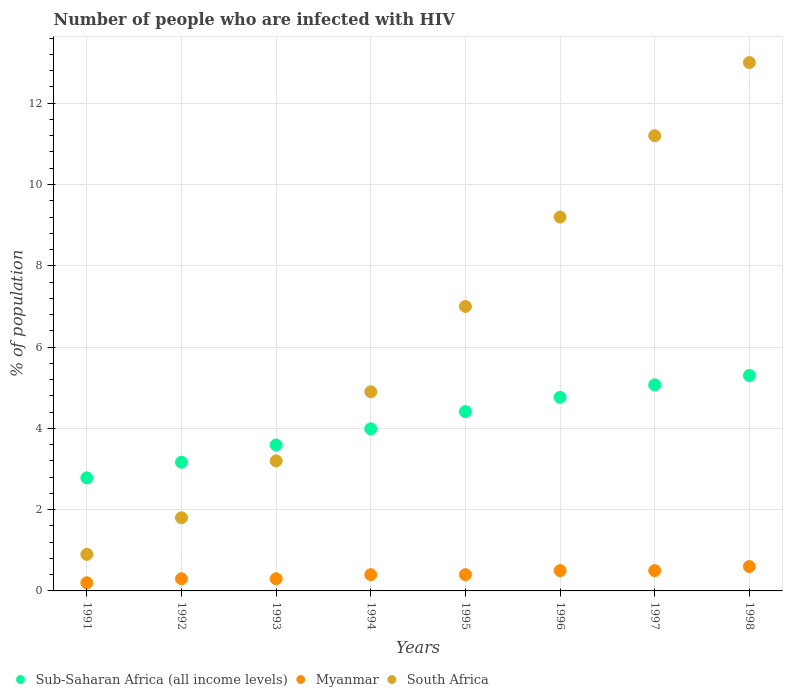What is the percentage of HIV infected population in in South Africa in 1993?
Make the answer very short. 3.2. Across all years, what is the minimum percentage of HIV infected population in in Sub-Saharan Africa (all income levels)?
Offer a terse response. 2.78. In which year was the percentage of HIV infected population in in Sub-Saharan Africa (all income levels) maximum?
Provide a succinct answer. 1998. In which year was the percentage of HIV infected population in in Myanmar minimum?
Give a very brief answer. 1991. What is the total percentage of HIV infected population in in South Africa in the graph?
Provide a succinct answer. 51.2. What is the difference between the percentage of HIV infected population in in Sub-Saharan Africa (all income levels) in 1991 and that in 1996?
Offer a terse response. -1.98. What is the average percentage of HIV infected population in in Sub-Saharan Africa (all income levels) per year?
Offer a very short reply. 4.13. In the year 1998, what is the difference between the percentage of HIV infected population in in Myanmar and percentage of HIV infected population in in South Africa?
Give a very brief answer. -12.4. What is the ratio of the percentage of HIV infected population in in South Africa in 1994 to that in 1996?
Provide a succinct answer. 0.53. Is the difference between the percentage of HIV infected population in in Myanmar in 1992 and 1997 greater than the difference between the percentage of HIV infected population in in South Africa in 1992 and 1997?
Offer a terse response. Yes. What is the difference between the highest and the second highest percentage of HIV infected population in in South Africa?
Make the answer very short. 1.8. What is the difference between the highest and the lowest percentage of HIV infected population in in Myanmar?
Give a very brief answer. 0.4. In how many years, is the percentage of HIV infected population in in Myanmar greater than the average percentage of HIV infected population in in Myanmar taken over all years?
Keep it short and to the point. 3. Does the percentage of HIV infected population in in South Africa monotonically increase over the years?
Provide a short and direct response. Yes. Is the percentage of HIV infected population in in Myanmar strictly greater than the percentage of HIV infected population in in South Africa over the years?
Make the answer very short. No. How many dotlines are there?
Provide a short and direct response. 3. What is the difference between two consecutive major ticks on the Y-axis?
Your answer should be very brief. 2. Are the values on the major ticks of Y-axis written in scientific E-notation?
Offer a very short reply. No. Where does the legend appear in the graph?
Your answer should be compact. Bottom left. What is the title of the graph?
Provide a short and direct response. Number of people who are infected with HIV. Does "Samoa" appear as one of the legend labels in the graph?
Your response must be concise. No. What is the label or title of the Y-axis?
Make the answer very short. % of population. What is the % of population in Sub-Saharan Africa (all income levels) in 1991?
Ensure brevity in your answer.  2.78. What is the % of population in Sub-Saharan Africa (all income levels) in 1992?
Keep it short and to the point. 3.17. What is the % of population of South Africa in 1992?
Give a very brief answer. 1.8. What is the % of population of Sub-Saharan Africa (all income levels) in 1993?
Ensure brevity in your answer.  3.59. What is the % of population in Myanmar in 1993?
Make the answer very short. 0.3. What is the % of population in Sub-Saharan Africa (all income levels) in 1994?
Provide a succinct answer. 3.99. What is the % of population of Sub-Saharan Africa (all income levels) in 1995?
Offer a very short reply. 4.41. What is the % of population in Myanmar in 1995?
Your answer should be very brief. 0.4. What is the % of population in South Africa in 1995?
Provide a succinct answer. 7. What is the % of population of Sub-Saharan Africa (all income levels) in 1996?
Make the answer very short. 4.76. What is the % of population in Sub-Saharan Africa (all income levels) in 1997?
Offer a very short reply. 5.07. What is the % of population of Myanmar in 1997?
Your response must be concise. 0.5. What is the % of population in Sub-Saharan Africa (all income levels) in 1998?
Offer a very short reply. 5.3. What is the % of population in Myanmar in 1998?
Provide a succinct answer. 0.6. Across all years, what is the maximum % of population in Sub-Saharan Africa (all income levels)?
Make the answer very short. 5.3. Across all years, what is the minimum % of population of Sub-Saharan Africa (all income levels)?
Give a very brief answer. 2.78. Across all years, what is the minimum % of population in Myanmar?
Ensure brevity in your answer.  0.2. What is the total % of population of Sub-Saharan Africa (all income levels) in the graph?
Your answer should be compact. 33.07. What is the total % of population in South Africa in the graph?
Your answer should be compact. 51.2. What is the difference between the % of population of Sub-Saharan Africa (all income levels) in 1991 and that in 1992?
Keep it short and to the point. -0.38. What is the difference between the % of population of Sub-Saharan Africa (all income levels) in 1991 and that in 1993?
Offer a terse response. -0.81. What is the difference between the % of population of South Africa in 1991 and that in 1993?
Keep it short and to the point. -2.3. What is the difference between the % of population in Sub-Saharan Africa (all income levels) in 1991 and that in 1994?
Your answer should be compact. -1.21. What is the difference between the % of population in Myanmar in 1991 and that in 1994?
Provide a succinct answer. -0.2. What is the difference between the % of population in South Africa in 1991 and that in 1994?
Make the answer very short. -4. What is the difference between the % of population in Sub-Saharan Africa (all income levels) in 1991 and that in 1995?
Keep it short and to the point. -1.63. What is the difference between the % of population of Sub-Saharan Africa (all income levels) in 1991 and that in 1996?
Offer a very short reply. -1.98. What is the difference between the % of population of Myanmar in 1991 and that in 1996?
Provide a short and direct response. -0.3. What is the difference between the % of population in South Africa in 1991 and that in 1996?
Provide a short and direct response. -8.3. What is the difference between the % of population in Sub-Saharan Africa (all income levels) in 1991 and that in 1997?
Provide a short and direct response. -2.29. What is the difference between the % of population of Sub-Saharan Africa (all income levels) in 1991 and that in 1998?
Your response must be concise. -2.52. What is the difference between the % of population of Myanmar in 1991 and that in 1998?
Make the answer very short. -0.4. What is the difference between the % of population of Sub-Saharan Africa (all income levels) in 1992 and that in 1993?
Offer a very short reply. -0.42. What is the difference between the % of population of Myanmar in 1992 and that in 1993?
Offer a terse response. 0. What is the difference between the % of population in South Africa in 1992 and that in 1993?
Keep it short and to the point. -1.4. What is the difference between the % of population of Sub-Saharan Africa (all income levels) in 1992 and that in 1994?
Offer a very short reply. -0.82. What is the difference between the % of population of Sub-Saharan Africa (all income levels) in 1992 and that in 1995?
Provide a succinct answer. -1.25. What is the difference between the % of population in Myanmar in 1992 and that in 1995?
Give a very brief answer. -0.1. What is the difference between the % of population of Sub-Saharan Africa (all income levels) in 1992 and that in 1996?
Keep it short and to the point. -1.6. What is the difference between the % of population of Myanmar in 1992 and that in 1996?
Offer a terse response. -0.2. What is the difference between the % of population of Sub-Saharan Africa (all income levels) in 1992 and that in 1997?
Ensure brevity in your answer.  -1.9. What is the difference between the % of population in Sub-Saharan Africa (all income levels) in 1992 and that in 1998?
Offer a terse response. -2.14. What is the difference between the % of population of Myanmar in 1992 and that in 1998?
Keep it short and to the point. -0.3. What is the difference between the % of population in South Africa in 1992 and that in 1998?
Make the answer very short. -11.2. What is the difference between the % of population in Sub-Saharan Africa (all income levels) in 1993 and that in 1994?
Ensure brevity in your answer.  -0.4. What is the difference between the % of population in Sub-Saharan Africa (all income levels) in 1993 and that in 1995?
Make the answer very short. -0.82. What is the difference between the % of population in Sub-Saharan Africa (all income levels) in 1993 and that in 1996?
Your answer should be very brief. -1.17. What is the difference between the % of population of South Africa in 1993 and that in 1996?
Your response must be concise. -6. What is the difference between the % of population in Sub-Saharan Africa (all income levels) in 1993 and that in 1997?
Give a very brief answer. -1.48. What is the difference between the % of population in Myanmar in 1993 and that in 1997?
Provide a succinct answer. -0.2. What is the difference between the % of population of South Africa in 1993 and that in 1997?
Offer a very short reply. -8. What is the difference between the % of population of Sub-Saharan Africa (all income levels) in 1993 and that in 1998?
Your answer should be very brief. -1.71. What is the difference between the % of population in Sub-Saharan Africa (all income levels) in 1994 and that in 1995?
Provide a short and direct response. -0.42. What is the difference between the % of population of Myanmar in 1994 and that in 1995?
Keep it short and to the point. 0. What is the difference between the % of population of Sub-Saharan Africa (all income levels) in 1994 and that in 1996?
Provide a succinct answer. -0.77. What is the difference between the % of population in South Africa in 1994 and that in 1996?
Give a very brief answer. -4.3. What is the difference between the % of population of Sub-Saharan Africa (all income levels) in 1994 and that in 1997?
Keep it short and to the point. -1.08. What is the difference between the % of population of South Africa in 1994 and that in 1997?
Provide a succinct answer. -6.3. What is the difference between the % of population of Sub-Saharan Africa (all income levels) in 1994 and that in 1998?
Make the answer very short. -1.31. What is the difference between the % of population of Sub-Saharan Africa (all income levels) in 1995 and that in 1996?
Provide a short and direct response. -0.35. What is the difference between the % of population in Myanmar in 1995 and that in 1996?
Your answer should be compact. -0.1. What is the difference between the % of population in Sub-Saharan Africa (all income levels) in 1995 and that in 1997?
Offer a terse response. -0.66. What is the difference between the % of population in Myanmar in 1995 and that in 1997?
Provide a succinct answer. -0.1. What is the difference between the % of population in Sub-Saharan Africa (all income levels) in 1995 and that in 1998?
Make the answer very short. -0.89. What is the difference between the % of population in Sub-Saharan Africa (all income levels) in 1996 and that in 1997?
Keep it short and to the point. -0.31. What is the difference between the % of population of Myanmar in 1996 and that in 1997?
Your response must be concise. 0. What is the difference between the % of population of Sub-Saharan Africa (all income levels) in 1996 and that in 1998?
Ensure brevity in your answer.  -0.54. What is the difference between the % of population in Myanmar in 1996 and that in 1998?
Ensure brevity in your answer.  -0.1. What is the difference between the % of population of Sub-Saharan Africa (all income levels) in 1997 and that in 1998?
Give a very brief answer. -0.23. What is the difference between the % of population in Myanmar in 1997 and that in 1998?
Your answer should be compact. -0.1. What is the difference between the % of population of South Africa in 1997 and that in 1998?
Make the answer very short. -1.8. What is the difference between the % of population of Sub-Saharan Africa (all income levels) in 1991 and the % of population of Myanmar in 1992?
Offer a very short reply. 2.48. What is the difference between the % of population of Sub-Saharan Africa (all income levels) in 1991 and the % of population of South Africa in 1992?
Provide a succinct answer. 0.98. What is the difference between the % of population in Sub-Saharan Africa (all income levels) in 1991 and the % of population in Myanmar in 1993?
Your response must be concise. 2.48. What is the difference between the % of population of Sub-Saharan Africa (all income levels) in 1991 and the % of population of South Africa in 1993?
Ensure brevity in your answer.  -0.42. What is the difference between the % of population of Sub-Saharan Africa (all income levels) in 1991 and the % of population of Myanmar in 1994?
Your response must be concise. 2.38. What is the difference between the % of population in Sub-Saharan Africa (all income levels) in 1991 and the % of population in South Africa in 1994?
Offer a very short reply. -2.12. What is the difference between the % of population of Myanmar in 1991 and the % of population of South Africa in 1994?
Offer a terse response. -4.7. What is the difference between the % of population in Sub-Saharan Africa (all income levels) in 1991 and the % of population in Myanmar in 1995?
Your response must be concise. 2.38. What is the difference between the % of population in Sub-Saharan Africa (all income levels) in 1991 and the % of population in South Africa in 1995?
Keep it short and to the point. -4.22. What is the difference between the % of population in Sub-Saharan Africa (all income levels) in 1991 and the % of population in Myanmar in 1996?
Ensure brevity in your answer.  2.28. What is the difference between the % of population in Sub-Saharan Africa (all income levels) in 1991 and the % of population in South Africa in 1996?
Make the answer very short. -6.42. What is the difference between the % of population of Myanmar in 1991 and the % of population of South Africa in 1996?
Ensure brevity in your answer.  -9. What is the difference between the % of population in Sub-Saharan Africa (all income levels) in 1991 and the % of population in Myanmar in 1997?
Provide a short and direct response. 2.28. What is the difference between the % of population in Sub-Saharan Africa (all income levels) in 1991 and the % of population in South Africa in 1997?
Your answer should be very brief. -8.42. What is the difference between the % of population of Myanmar in 1991 and the % of population of South Africa in 1997?
Give a very brief answer. -11. What is the difference between the % of population of Sub-Saharan Africa (all income levels) in 1991 and the % of population of Myanmar in 1998?
Offer a very short reply. 2.18. What is the difference between the % of population in Sub-Saharan Africa (all income levels) in 1991 and the % of population in South Africa in 1998?
Your response must be concise. -10.22. What is the difference between the % of population of Sub-Saharan Africa (all income levels) in 1992 and the % of population of Myanmar in 1993?
Offer a very short reply. 2.87. What is the difference between the % of population in Sub-Saharan Africa (all income levels) in 1992 and the % of population in South Africa in 1993?
Give a very brief answer. -0.03. What is the difference between the % of population of Myanmar in 1992 and the % of population of South Africa in 1993?
Your answer should be very brief. -2.9. What is the difference between the % of population of Sub-Saharan Africa (all income levels) in 1992 and the % of population of Myanmar in 1994?
Provide a succinct answer. 2.77. What is the difference between the % of population of Sub-Saharan Africa (all income levels) in 1992 and the % of population of South Africa in 1994?
Offer a very short reply. -1.73. What is the difference between the % of population in Myanmar in 1992 and the % of population in South Africa in 1994?
Your answer should be very brief. -4.6. What is the difference between the % of population in Sub-Saharan Africa (all income levels) in 1992 and the % of population in Myanmar in 1995?
Offer a very short reply. 2.77. What is the difference between the % of population of Sub-Saharan Africa (all income levels) in 1992 and the % of population of South Africa in 1995?
Your response must be concise. -3.83. What is the difference between the % of population of Sub-Saharan Africa (all income levels) in 1992 and the % of population of Myanmar in 1996?
Offer a terse response. 2.67. What is the difference between the % of population of Sub-Saharan Africa (all income levels) in 1992 and the % of population of South Africa in 1996?
Keep it short and to the point. -6.03. What is the difference between the % of population of Myanmar in 1992 and the % of population of South Africa in 1996?
Make the answer very short. -8.9. What is the difference between the % of population of Sub-Saharan Africa (all income levels) in 1992 and the % of population of Myanmar in 1997?
Your answer should be very brief. 2.67. What is the difference between the % of population in Sub-Saharan Africa (all income levels) in 1992 and the % of population in South Africa in 1997?
Provide a short and direct response. -8.03. What is the difference between the % of population of Sub-Saharan Africa (all income levels) in 1992 and the % of population of Myanmar in 1998?
Offer a terse response. 2.57. What is the difference between the % of population in Sub-Saharan Africa (all income levels) in 1992 and the % of population in South Africa in 1998?
Offer a very short reply. -9.83. What is the difference between the % of population in Myanmar in 1992 and the % of population in South Africa in 1998?
Keep it short and to the point. -12.7. What is the difference between the % of population of Sub-Saharan Africa (all income levels) in 1993 and the % of population of Myanmar in 1994?
Make the answer very short. 3.19. What is the difference between the % of population in Sub-Saharan Africa (all income levels) in 1993 and the % of population in South Africa in 1994?
Offer a very short reply. -1.31. What is the difference between the % of population of Sub-Saharan Africa (all income levels) in 1993 and the % of population of Myanmar in 1995?
Provide a short and direct response. 3.19. What is the difference between the % of population of Sub-Saharan Africa (all income levels) in 1993 and the % of population of South Africa in 1995?
Provide a succinct answer. -3.41. What is the difference between the % of population of Myanmar in 1993 and the % of population of South Africa in 1995?
Your answer should be compact. -6.7. What is the difference between the % of population of Sub-Saharan Africa (all income levels) in 1993 and the % of population of Myanmar in 1996?
Your answer should be compact. 3.09. What is the difference between the % of population in Sub-Saharan Africa (all income levels) in 1993 and the % of population in South Africa in 1996?
Make the answer very short. -5.61. What is the difference between the % of population of Sub-Saharan Africa (all income levels) in 1993 and the % of population of Myanmar in 1997?
Make the answer very short. 3.09. What is the difference between the % of population in Sub-Saharan Africa (all income levels) in 1993 and the % of population in South Africa in 1997?
Your answer should be very brief. -7.61. What is the difference between the % of population in Myanmar in 1993 and the % of population in South Africa in 1997?
Your answer should be compact. -10.9. What is the difference between the % of population of Sub-Saharan Africa (all income levels) in 1993 and the % of population of Myanmar in 1998?
Offer a very short reply. 2.99. What is the difference between the % of population in Sub-Saharan Africa (all income levels) in 1993 and the % of population in South Africa in 1998?
Provide a succinct answer. -9.41. What is the difference between the % of population of Sub-Saharan Africa (all income levels) in 1994 and the % of population of Myanmar in 1995?
Keep it short and to the point. 3.59. What is the difference between the % of population of Sub-Saharan Africa (all income levels) in 1994 and the % of population of South Africa in 1995?
Provide a succinct answer. -3.01. What is the difference between the % of population of Myanmar in 1994 and the % of population of South Africa in 1995?
Keep it short and to the point. -6.6. What is the difference between the % of population in Sub-Saharan Africa (all income levels) in 1994 and the % of population in Myanmar in 1996?
Ensure brevity in your answer.  3.49. What is the difference between the % of population in Sub-Saharan Africa (all income levels) in 1994 and the % of population in South Africa in 1996?
Your response must be concise. -5.21. What is the difference between the % of population of Myanmar in 1994 and the % of population of South Africa in 1996?
Give a very brief answer. -8.8. What is the difference between the % of population of Sub-Saharan Africa (all income levels) in 1994 and the % of population of Myanmar in 1997?
Ensure brevity in your answer.  3.49. What is the difference between the % of population in Sub-Saharan Africa (all income levels) in 1994 and the % of population in South Africa in 1997?
Your answer should be compact. -7.21. What is the difference between the % of population in Sub-Saharan Africa (all income levels) in 1994 and the % of population in Myanmar in 1998?
Offer a terse response. 3.39. What is the difference between the % of population in Sub-Saharan Africa (all income levels) in 1994 and the % of population in South Africa in 1998?
Give a very brief answer. -9.01. What is the difference between the % of population in Myanmar in 1994 and the % of population in South Africa in 1998?
Provide a short and direct response. -12.6. What is the difference between the % of population in Sub-Saharan Africa (all income levels) in 1995 and the % of population in Myanmar in 1996?
Offer a terse response. 3.91. What is the difference between the % of population of Sub-Saharan Africa (all income levels) in 1995 and the % of population of South Africa in 1996?
Your response must be concise. -4.79. What is the difference between the % of population in Myanmar in 1995 and the % of population in South Africa in 1996?
Provide a succinct answer. -8.8. What is the difference between the % of population in Sub-Saharan Africa (all income levels) in 1995 and the % of population in Myanmar in 1997?
Offer a terse response. 3.91. What is the difference between the % of population of Sub-Saharan Africa (all income levels) in 1995 and the % of population of South Africa in 1997?
Offer a terse response. -6.79. What is the difference between the % of population in Myanmar in 1995 and the % of population in South Africa in 1997?
Provide a succinct answer. -10.8. What is the difference between the % of population in Sub-Saharan Africa (all income levels) in 1995 and the % of population in Myanmar in 1998?
Give a very brief answer. 3.81. What is the difference between the % of population in Sub-Saharan Africa (all income levels) in 1995 and the % of population in South Africa in 1998?
Your answer should be very brief. -8.59. What is the difference between the % of population of Myanmar in 1995 and the % of population of South Africa in 1998?
Make the answer very short. -12.6. What is the difference between the % of population in Sub-Saharan Africa (all income levels) in 1996 and the % of population in Myanmar in 1997?
Make the answer very short. 4.26. What is the difference between the % of population in Sub-Saharan Africa (all income levels) in 1996 and the % of population in South Africa in 1997?
Offer a terse response. -6.44. What is the difference between the % of population in Myanmar in 1996 and the % of population in South Africa in 1997?
Offer a terse response. -10.7. What is the difference between the % of population of Sub-Saharan Africa (all income levels) in 1996 and the % of population of Myanmar in 1998?
Your answer should be compact. 4.16. What is the difference between the % of population in Sub-Saharan Africa (all income levels) in 1996 and the % of population in South Africa in 1998?
Provide a succinct answer. -8.24. What is the difference between the % of population of Sub-Saharan Africa (all income levels) in 1997 and the % of population of Myanmar in 1998?
Keep it short and to the point. 4.47. What is the difference between the % of population of Sub-Saharan Africa (all income levels) in 1997 and the % of population of South Africa in 1998?
Your response must be concise. -7.93. What is the average % of population in Sub-Saharan Africa (all income levels) per year?
Your response must be concise. 4.13. What is the average % of population of Myanmar per year?
Your answer should be compact. 0.4. In the year 1991, what is the difference between the % of population of Sub-Saharan Africa (all income levels) and % of population of Myanmar?
Offer a terse response. 2.58. In the year 1991, what is the difference between the % of population in Sub-Saharan Africa (all income levels) and % of population in South Africa?
Ensure brevity in your answer.  1.88. In the year 1991, what is the difference between the % of population of Myanmar and % of population of South Africa?
Your answer should be compact. -0.7. In the year 1992, what is the difference between the % of population in Sub-Saharan Africa (all income levels) and % of population in Myanmar?
Your answer should be very brief. 2.87. In the year 1992, what is the difference between the % of population in Sub-Saharan Africa (all income levels) and % of population in South Africa?
Your answer should be very brief. 1.37. In the year 1992, what is the difference between the % of population of Myanmar and % of population of South Africa?
Provide a short and direct response. -1.5. In the year 1993, what is the difference between the % of population of Sub-Saharan Africa (all income levels) and % of population of Myanmar?
Offer a very short reply. 3.29. In the year 1993, what is the difference between the % of population of Sub-Saharan Africa (all income levels) and % of population of South Africa?
Keep it short and to the point. 0.39. In the year 1993, what is the difference between the % of population in Myanmar and % of population in South Africa?
Your answer should be compact. -2.9. In the year 1994, what is the difference between the % of population of Sub-Saharan Africa (all income levels) and % of population of Myanmar?
Ensure brevity in your answer.  3.59. In the year 1994, what is the difference between the % of population in Sub-Saharan Africa (all income levels) and % of population in South Africa?
Give a very brief answer. -0.91. In the year 1994, what is the difference between the % of population in Myanmar and % of population in South Africa?
Make the answer very short. -4.5. In the year 1995, what is the difference between the % of population in Sub-Saharan Africa (all income levels) and % of population in Myanmar?
Your answer should be very brief. 4.01. In the year 1995, what is the difference between the % of population in Sub-Saharan Africa (all income levels) and % of population in South Africa?
Make the answer very short. -2.59. In the year 1996, what is the difference between the % of population in Sub-Saharan Africa (all income levels) and % of population in Myanmar?
Offer a terse response. 4.26. In the year 1996, what is the difference between the % of population in Sub-Saharan Africa (all income levels) and % of population in South Africa?
Offer a terse response. -4.44. In the year 1996, what is the difference between the % of population of Myanmar and % of population of South Africa?
Your response must be concise. -8.7. In the year 1997, what is the difference between the % of population in Sub-Saharan Africa (all income levels) and % of population in Myanmar?
Make the answer very short. 4.57. In the year 1997, what is the difference between the % of population in Sub-Saharan Africa (all income levels) and % of population in South Africa?
Keep it short and to the point. -6.13. In the year 1997, what is the difference between the % of population of Myanmar and % of population of South Africa?
Provide a short and direct response. -10.7. In the year 1998, what is the difference between the % of population of Sub-Saharan Africa (all income levels) and % of population of Myanmar?
Give a very brief answer. 4.7. In the year 1998, what is the difference between the % of population of Sub-Saharan Africa (all income levels) and % of population of South Africa?
Your answer should be compact. -7.7. In the year 1998, what is the difference between the % of population of Myanmar and % of population of South Africa?
Your answer should be compact. -12.4. What is the ratio of the % of population in Sub-Saharan Africa (all income levels) in 1991 to that in 1992?
Keep it short and to the point. 0.88. What is the ratio of the % of population in Myanmar in 1991 to that in 1992?
Your answer should be compact. 0.67. What is the ratio of the % of population of South Africa in 1991 to that in 1992?
Keep it short and to the point. 0.5. What is the ratio of the % of population of Sub-Saharan Africa (all income levels) in 1991 to that in 1993?
Offer a very short reply. 0.77. What is the ratio of the % of population of Myanmar in 1991 to that in 1993?
Ensure brevity in your answer.  0.67. What is the ratio of the % of population of South Africa in 1991 to that in 1993?
Offer a terse response. 0.28. What is the ratio of the % of population of Sub-Saharan Africa (all income levels) in 1991 to that in 1994?
Ensure brevity in your answer.  0.7. What is the ratio of the % of population of South Africa in 1991 to that in 1994?
Provide a succinct answer. 0.18. What is the ratio of the % of population of Sub-Saharan Africa (all income levels) in 1991 to that in 1995?
Your answer should be compact. 0.63. What is the ratio of the % of population in Myanmar in 1991 to that in 1995?
Keep it short and to the point. 0.5. What is the ratio of the % of population in South Africa in 1991 to that in 1995?
Provide a succinct answer. 0.13. What is the ratio of the % of population of Sub-Saharan Africa (all income levels) in 1991 to that in 1996?
Keep it short and to the point. 0.58. What is the ratio of the % of population of South Africa in 1991 to that in 1996?
Keep it short and to the point. 0.1. What is the ratio of the % of population of Sub-Saharan Africa (all income levels) in 1991 to that in 1997?
Your response must be concise. 0.55. What is the ratio of the % of population of South Africa in 1991 to that in 1997?
Keep it short and to the point. 0.08. What is the ratio of the % of population of Sub-Saharan Africa (all income levels) in 1991 to that in 1998?
Provide a succinct answer. 0.52. What is the ratio of the % of population of Myanmar in 1991 to that in 1998?
Provide a short and direct response. 0.33. What is the ratio of the % of population of South Africa in 1991 to that in 1998?
Your response must be concise. 0.07. What is the ratio of the % of population in Sub-Saharan Africa (all income levels) in 1992 to that in 1993?
Your response must be concise. 0.88. What is the ratio of the % of population of Myanmar in 1992 to that in 1993?
Offer a terse response. 1. What is the ratio of the % of population of South Africa in 1992 to that in 1993?
Give a very brief answer. 0.56. What is the ratio of the % of population in Sub-Saharan Africa (all income levels) in 1992 to that in 1994?
Provide a short and direct response. 0.79. What is the ratio of the % of population in South Africa in 1992 to that in 1994?
Offer a terse response. 0.37. What is the ratio of the % of population of Sub-Saharan Africa (all income levels) in 1992 to that in 1995?
Provide a short and direct response. 0.72. What is the ratio of the % of population in Myanmar in 1992 to that in 1995?
Give a very brief answer. 0.75. What is the ratio of the % of population of South Africa in 1992 to that in 1995?
Keep it short and to the point. 0.26. What is the ratio of the % of population in Sub-Saharan Africa (all income levels) in 1992 to that in 1996?
Your answer should be very brief. 0.66. What is the ratio of the % of population in South Africa in 1992 to that in 1996?
Ensure brevity in your answer.  0.2. What is the ratio of the % of population in Sub-Saharan Africa (all income levels) in 1992 to that in 1997?
Provide a succinct answer. 0.62. What is the ratio of the % of population of South Africa in 1992 to that in 1997?
Your answer should be very brief. 0.16. What is the ratio of the % of population in Sub-Saharan Africa (all income levels) in 1992 to that in 1998?
Make the answer very short. 0.6. What is the ratio of the % of population in South Africa in 1992 to that in 1998?
Offer a very short reply. 0.14. What is the ratio of the % of population in Sub-Saharan Africa (all income levels) in 1993 to that in 1994?
Keep it short and to the point. 0.9. What is the ratio of the % of population in South Africa in 1993 to that in 1994?
Provide a succinct answer. 0.65. What is the ratio of the % of population in Sub-Saharan Africa (all income levels) in 1993 to that in 1995?
Make the answer very short. 0.81. What is the ratio of the % of population of South Africa in 1993 to that in 1995?
Keep it short and to the point. 0.46. What is the ratio of the % of population of Sub-Saharan Africa (all income levels) in 1993 to that in 1996?
Your answer should be compact. 0.75. What is the ratio of the % of population in South Africa in 1993 to that in 1996?
Make the answer very short. 0.35. What is the ratio of the % of population of Sub-Saharan Africa (all income levels) in 1993 to that in 1997?
Provide a short and direct response. 0.71. What is the ratio of the % of population in Myanmar in 1993 to that in 1997?
Your answer should be compact. 0.6. What is the ratio of the % of population of South Africa in 1993 to that in 1997?
Keep it short and to the point. 0.29. What is the ratio of the % of population in Sub-Saharan Africa (all income levels) in 1993 to that in 1998?
Keep it short and to the point. 0.68. What is the ratio of the % of population of Myanmar in 1993 to that in 1998?
Give a very brief answer. 0.5. What is the ratio of the % of population of South Africa in 1993 to that in 1998?
Ensure brevity in your answer.  0.25. What is the ratio of the % of population of Sub-Saharan Africa (all income levels) in 1994 to that in 1995?
Offer a very short reply. 0.9. What is the ratio of the % of population in Myanmar in 1994 to that in 1995?
Keep it short and to the point. 1. What is the ratio of the % of population in South Africa in 1994 to that in 1995?
Your answer should be compact. 0.7. What is the ratio of the % of population of Sub-Saharan Africa (all income levels) in 1994 to that in 1996?
Offer a very short reply. 0.84. What is the ratio of the % of population in Myanmar in 1994 to that in 1996?
Provide a succinct answer. 0.8. What is the ratio of the % of population in South Africa in 1994 to that in 1996?
Give a very brief answer. 0.53. What is the ratio of the % of population in Sub-Saharan Africa (all income levels) in 1994 to that in 1997?
Your answer should be compact. 0.79. What is the ratio of the % of population in South Africa in 1994 to that in 1997?
Ensure brevity in your answer.  0.44. What is the ratio of the % of population of Sub-Saharan Africa (all income levels) in 1994 to that in 1998?
Provide a short and direct response. 0.75. What is the ratio of the % of population in Myanmar in 1994 to that in 1998?
Provide a succinct answer. 0.67. What is the ratio of the % of population in South Africa in 1994 to that in 1998?
Offer a very short reply. 0.38. What is the ratio of the % of population in Sub-Saharan Africa (all income levels) in 1995 to that in 1996?
Make the answer very short. 0.93. What is the ratio of the % of population in South Africa in 1995 to that in 1996?
Provide a succinct answer. 0.76. What is the ratio of the % of population in Sub-Saharan Africa (all income levels) in 1995 to that in 1997?
Your response must be concise. 0.87. What is the ratio of the % of population in Sub-Saharan Africa (all income levels) in 1995 to that in 1998?
Provide a short and direct response. 0.83. What is the ratio of the % of population of South Africa in 1995 to that in 1998?
Give a very brief answer. 0.54. What is the ratio of the % of population of Sub-Saharan Africa (all income levels) in 1996 to that in 1997?
Your answer should be very brief. 0.94. What is the ratio of the % of population of South Africa in 1996 to that in 1997?
Make the answer very short. 0.82. What is the ratio of the % of population of Sub-Saharan Africa (all income levels) in 1996 to that in 1998?
Keep it short and to the point. 0.9. What is the ratio of the % of population in South Africa in 1996 to that in 1998?
Your answer should be very brief. 0.71. What is the ratio of the % of population in Sub-Saharan Africa (all income levels) in 1997 to that in 1998?
Give a very brief answer. 0.96. What is the ratio of the % of population of Myanmar in 1997 to that in 1998?
Your answer should be compact. 0.83. What is the ratio of the % of population of South Africa in 1997 to that in 1998?
Provide a succinct answer. 0.86. What is the difference between the highest and the second highest % of population of Sub-Saharan Africa (all income levels)?
Provide a succinct answer. 0.23. What is the difference between the highest and the second highest % of population in South Africa?
Give a very brief answer. 1.8. What is the difference between the highest and the lowest % of population of Sub-Saharan Africa (all income levels)?
Make the answer very short. 2.52. 